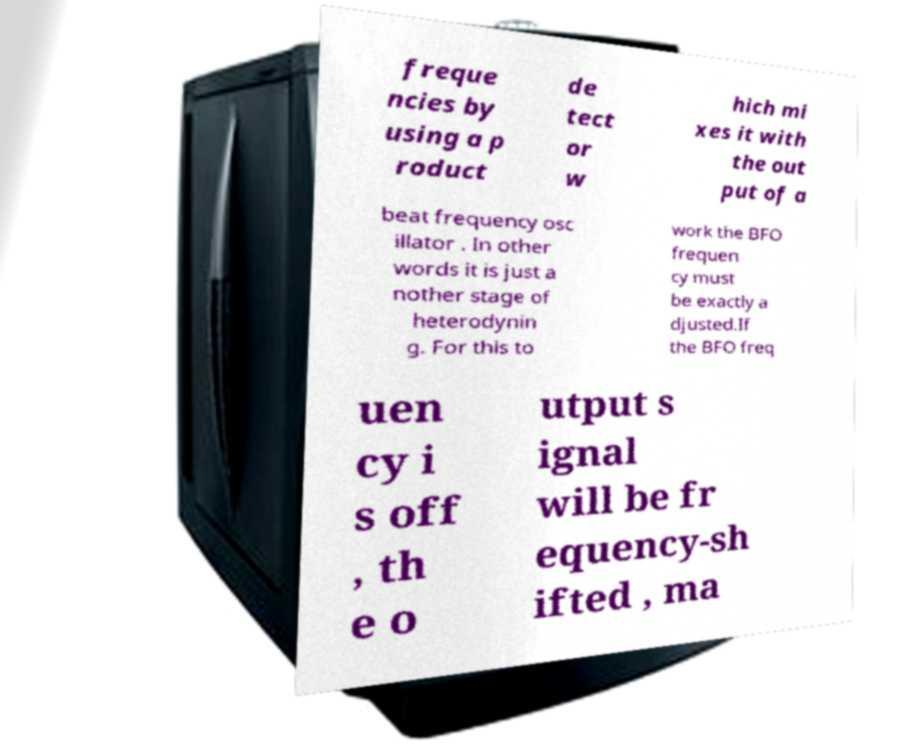Could you assist in decoding the text presented in this image and type it out clearly? freque ncies by using a p roduct de tect or w hich mi xes it with the out put of a beat frequency osc illator . In other words it is just a nother stage of heterodynin g. For this to work the BFO frequen cy must be exactly a djusted.If the BFO freq uen cy i s off , th e o utput s ignal will be fr equency-sh ifted , ma 